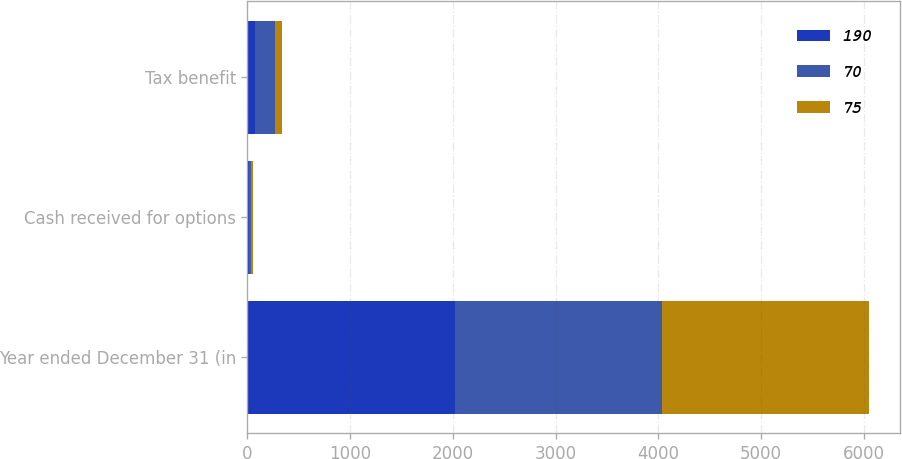Convert chart to OTSL. <chart><loc_0><loc_0><loc_500><loc_500><stacked_bar_chart><ecel><fcel>Year ended December 31 (in<fcel>Cash received for options<fcel>Tax benefit<nl><fcel>190<fcel>2018<fcel>14<fcel>75<nl><fcel>70<fcel>2017<fcel>18<fcel>190<nl><fcel>75<fcel>2016<fcel>26<fcel>70<nl></chart> 